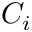Convert formula to latex. <formula><loc_0><loc_0><loc_500><loc_500>C _ { i }</formula> 